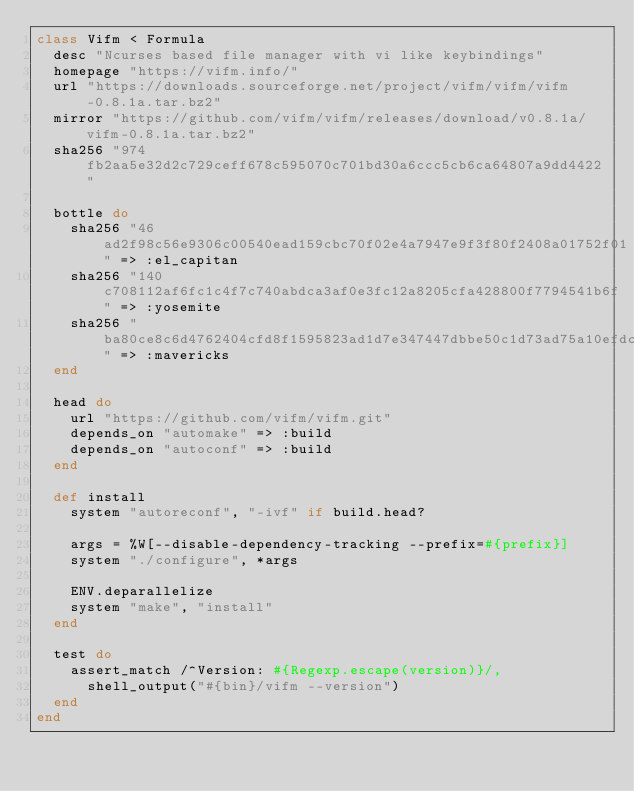Convert code to text. <code><loc_0><loc_0><loc_500><loc_500><_Ruby_>class Vifm < Formula
  desc "Ncurses based file manager with vi like keybindings"
  homepage "https://vifm.info/"
  url "https://downloads.sourceforge.net/project/vifm/vifm/vifm-0.8.1a.tar.bz2"
  mirror "https://github.com/vifm/vifm/releases/download/v0.8.1a/vifm-0.8.1a.tar.bz2"
  sha256 "974fb2aa5e32d2c729ceff678c595070c701bd30a6ccc5cb6ca64807a9dd4422"

  bottle do
    sha256 "46ad2f98c56e9306c00540ead159cbc70f02e4a7947e9f3f80f2408a01752f01" => :el_capitan
    sha256 "140c708112af6fc1c4f7c740abdca3af0e3fc12a8205cfa428800f7794541b6f" => :yosemite
    sha256 "ba80ce8c6d4762404cfd8f1595823ad1d7e347447dbbe50c1d73ad75a10efdcf" => :mavericks
  end

  head do
    url "https://github.com/vifm/vifm.git"
    depends_on "automake" => :build
    depends_on "autoconf" => :build
  end

  def install
    system "autoreconf", "-ivf" if build.head?

    args = %W[--disable-dependency-tracking --prefix=#{prefix}]
    system "./configure", *args

    ENV.deparallelize
    system "make", "install"
  end

  test do
    assert_match /^Version: #{Regexp.escape(version)}/,
      shell_output("#{bin}/vifm --version")
  end
end
</code> 